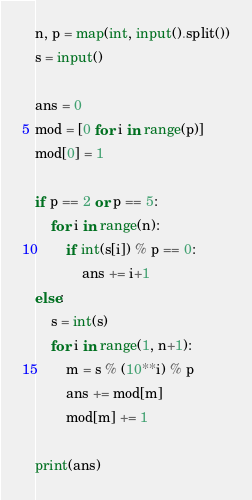Convert code to text. <code><loc_0><loc_0><loc_500><loc_500><_Python_>n, p = map(int, input().split())
s = input()

ans = 0
mod = [0 for i in range(p)]
mod[0] = 1

if p == 2 or p == 5:
    for i in range(n):
        if int(s[i]) % p == 0:
            ans += i+1
else:
    s = int(s)
    for i in range(1, n+1):
        m = s % (10**i) % p
        ans += mod[m]
        mod[m] += 1

print(ans)
</code> 